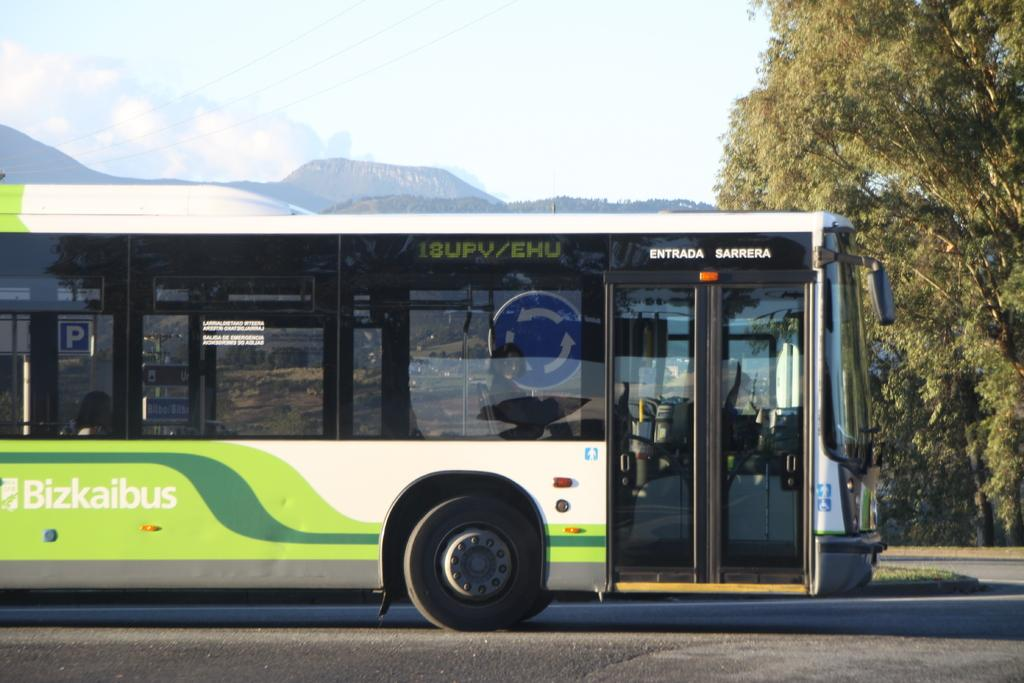What is located on the left side of the image? There is a bus on the left side of the image. What feature can be observed on the bus? The bus has glass windows. Where is the bus situated? The bus is on a road. What type of vegetation is on the right side of the image? There are trees on the right side of the image. What can be seen in the background of the image? There are mountains and clouds in the background of the image. What type of button can be seen causing trouble for the bus driver in the image? There is no button or trouble for the bus driver present in the image. How is the waste being managed in the image? There is no waste management depicted in the image; it focuses on the bus, trees, mountains, and clouds. 